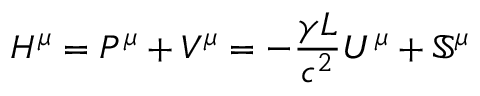<formula> <loc_0><loc_0><loc_500><loc_500>H ^ { \mu } = P ^ { \mu } + V ^ { \mu } = - \frac { \gamma L } { c ^ { 2 } } U ^ { \mu } + \mathbb { S } ^ { \mu }</formula> 